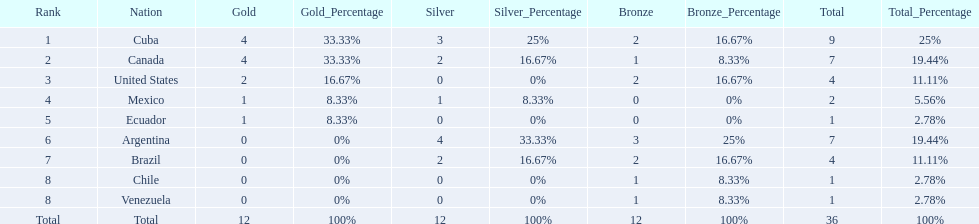What is the total number of nations that did not win gold? 4. 